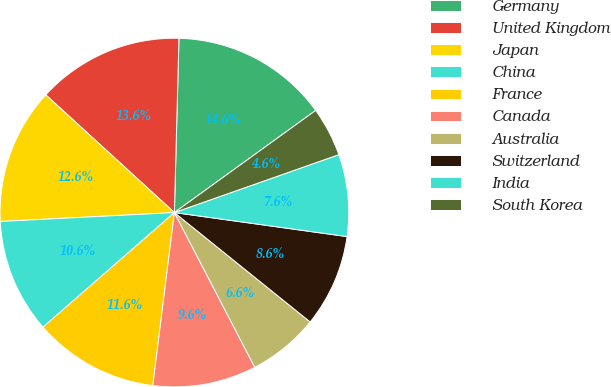Convert chart to OTSL. <chart><loc_0><loc_0><loc_500><loc_500><pie_chart><fcel>Germany<fcel>United Kingdom<fcel>Japan<fcel>China<fcel>France<fcel>Canada<fcel>Australia<fcel>Switzerland<fcel>India<fcel>South Korea<nl><fcel>14.62%<fcel>13.62%<fcel>12.61%<fcel>10.6%<fcel>11.61%<fcel>9.6%<fcel>6.58%<fcel>8.59%<fcel>7.59%<fcel>4.57%<nl></chart> 